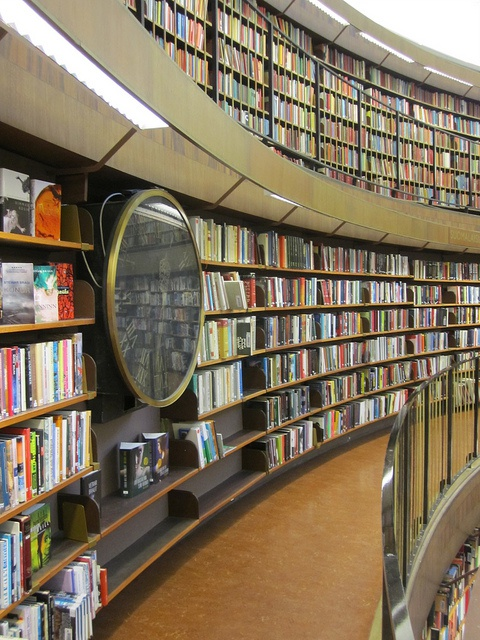Describe the objects in this image and their specific colors. I can see book in white, black, darkgray, gray, and tan tones, clock in white, gray, black, and olive tones, book in white, darkgray, lightgray, gray, and black tones, book in white, lime, olive, lightgreen, and yellow tones, and clock in white, lightblue, darkgray, and gray tones in this image. 